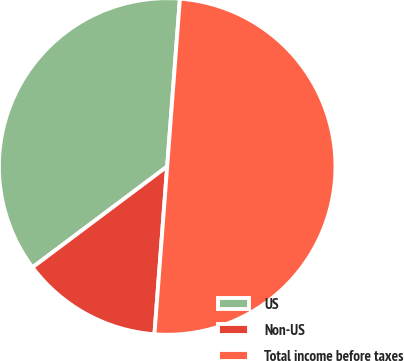<chart> <loc_0><loc_0><loc_500><loc_500><pie_chart><fcel>US<fcel>Non-US<fcel>Total income before taxes<nl><fcel>36.44%<fcel>13.56%<fcel>50.0%<nl></chart> 